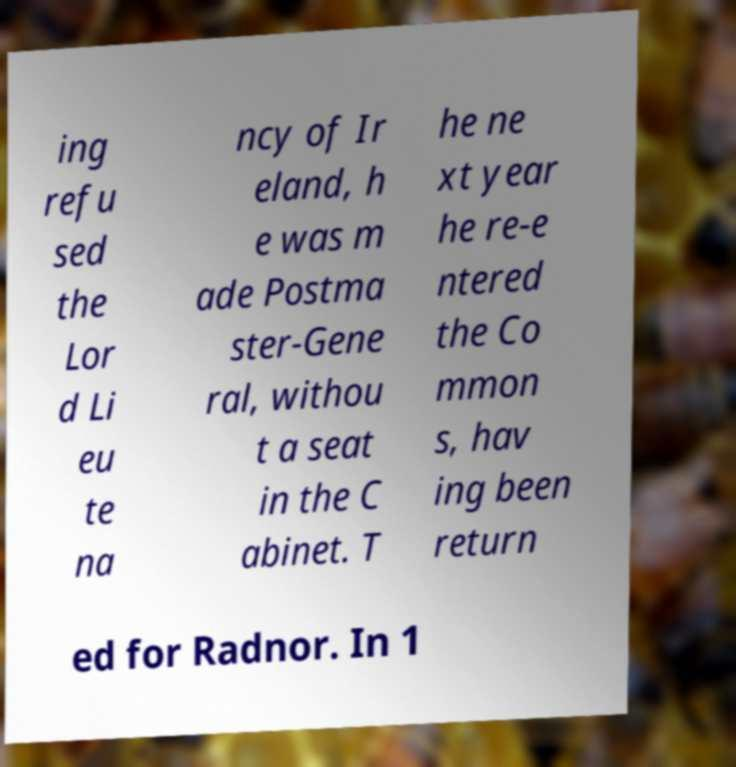Can you read and provide the text displayed in the image?This photo seems to have some interesting text. Can you extract and type it out for me? ing refu sed the Lor d Li eu te na ncy of Ir eland, h e was m ade Postma ster-Gene ral, withou t a seat in the C abinet. T he ne xt year he re-e ntered the Co mmon s, hav ing been return ed for Radnor. In 1 